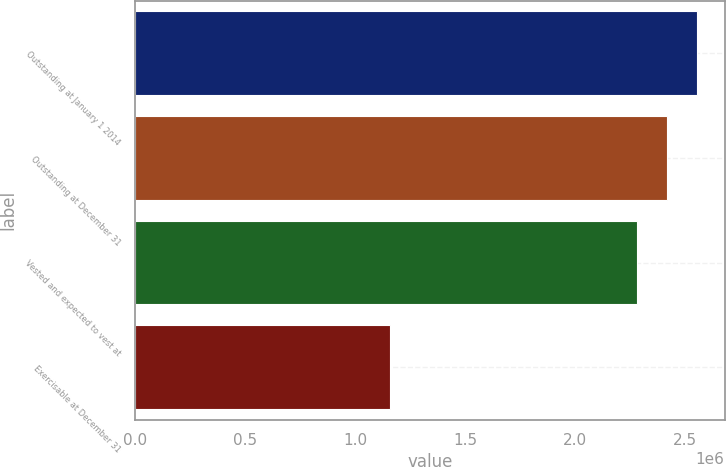<chart> <loc_0><loc_0><loc_500><loc_500><bar_chart><fcel>Outstanding at January 1 2014<fcel>Outstanding at December 31<fcel>Vested and expected to vest at<fcel>Exercisable at December 31<nl><fcel>2.55121e+06<fcel>2.41533e+06<fcel>2.27944e+06<fcel>1.1578e+06<nl></chart> 